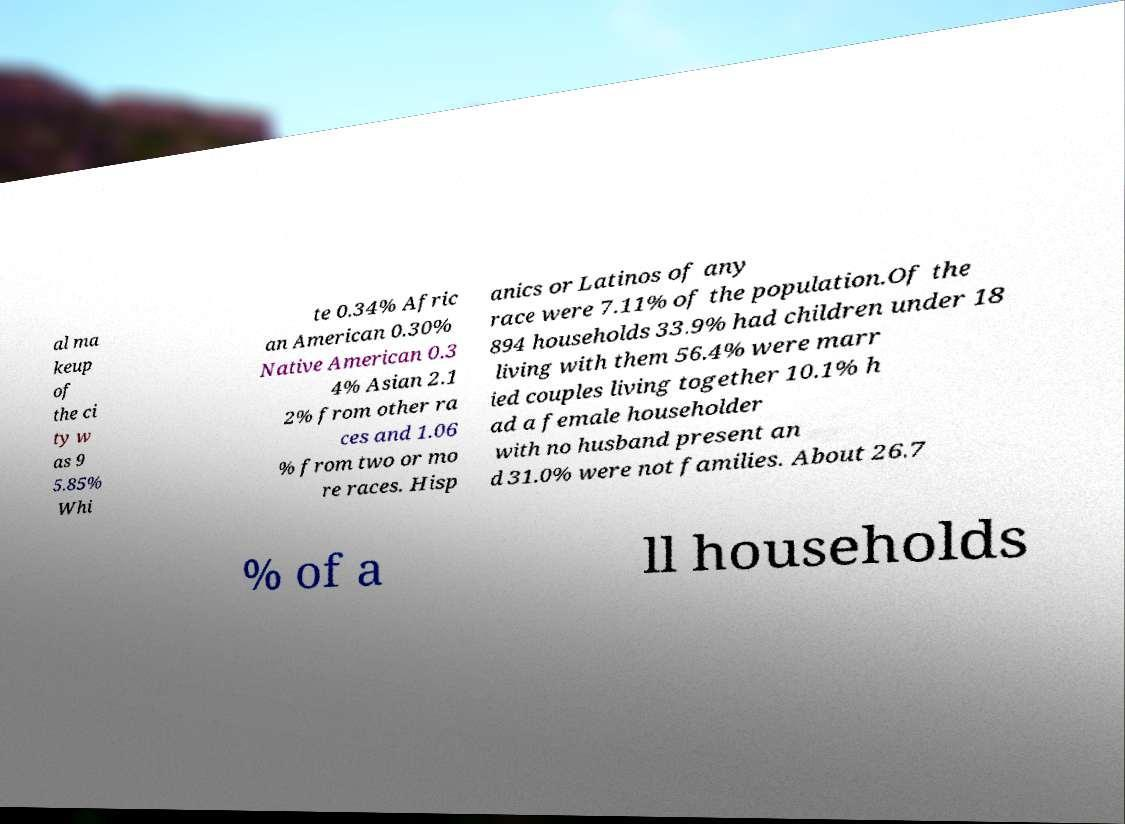Could you extract and type out the text from this image? al ma keup of the ci ty w as 9 5.85% Whi te 0.34% Afric an American 0.30% Native American 0.3 4% Asian 2.1 2% from other ra ces and 1.06 % from two or mo re races. Hisp anics or Latinos of any race were 7.11% of the population.Of the 894 households 33.9% had children under 18 living with them 56.4% were marr ied couples living together 10.1% h ad a female householder with no husband present an d 31.0% were not families. About 26.7 % of a ll households 